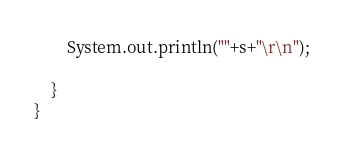<code> <loc_0><loc_0><loc_500><loc_500><_Java_>
        System.out.println(""+s+"\r\n");

    }
}
</code> 